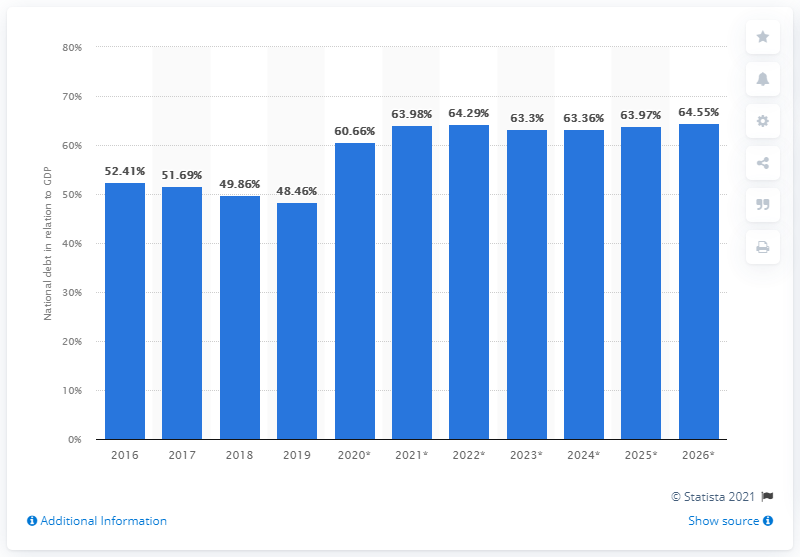Highlight a few significant elements in this photo. In 2019, the national debt of Slovakia accounted for 48.46% of the country's Gross Domestic Product (GDP), a significant proportion of the overall economy. 